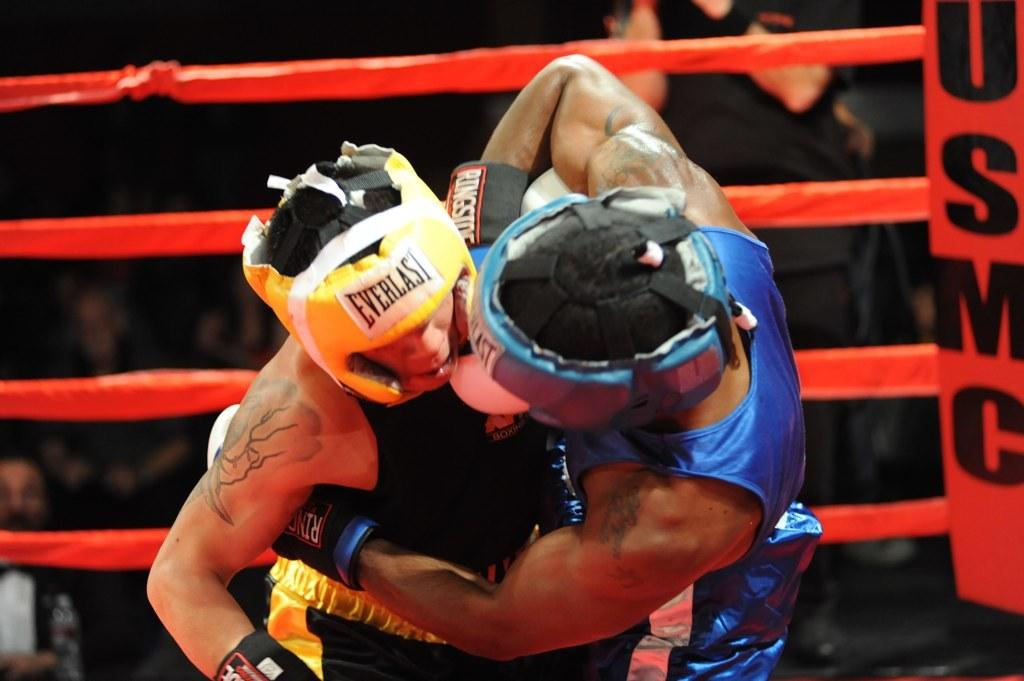How many people are in the image? There is a group of people in the image. Can you describe the two persons in the middle of the image? The two persons in the middle of the image are wearing helmets and gloves. What can be seen in the image that might be used for climbing or support? There are ropes visible in the image. What is the amount of heart in the image? There is no mention of a heart in the image, so it is not possible to determine an amount. 